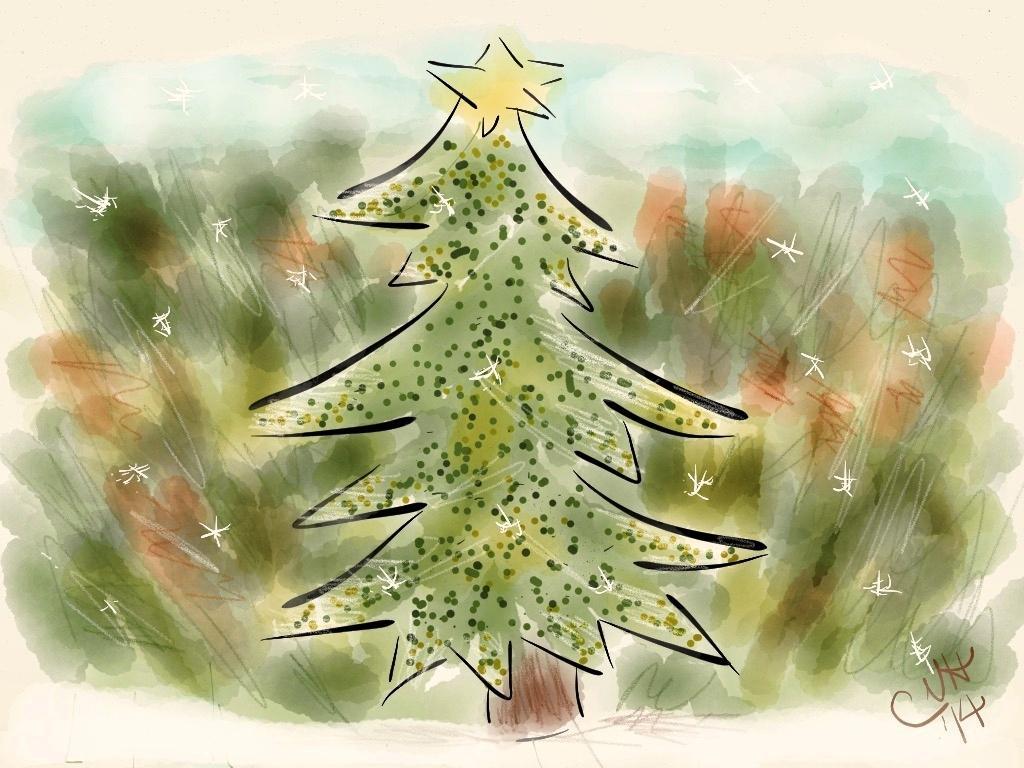Could you give a brief overview of what you see in this image? In this picture there is a tree and the background is greenery. 